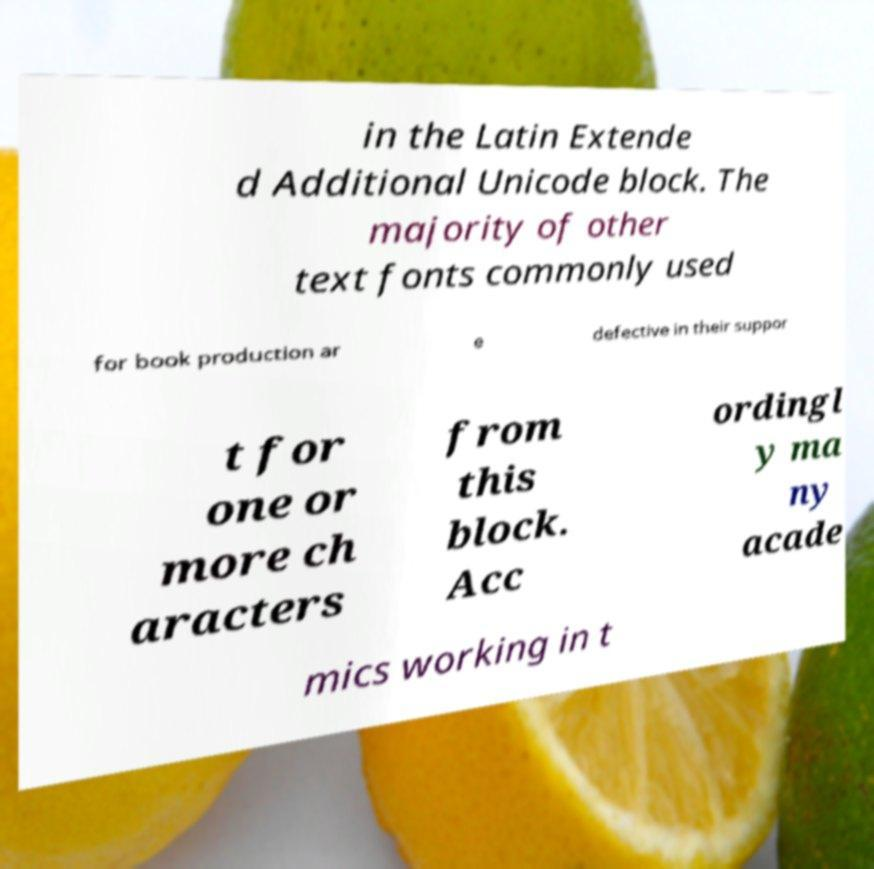Please identify and transcribe the text found in this image. in the Latin Extende d Additional Unicode block. The majority of other text fonts commonly used for book production ar e defective in their suppor t for one or more ch aracters from this block. Acc ordingl y ma ny acade mics working in t 